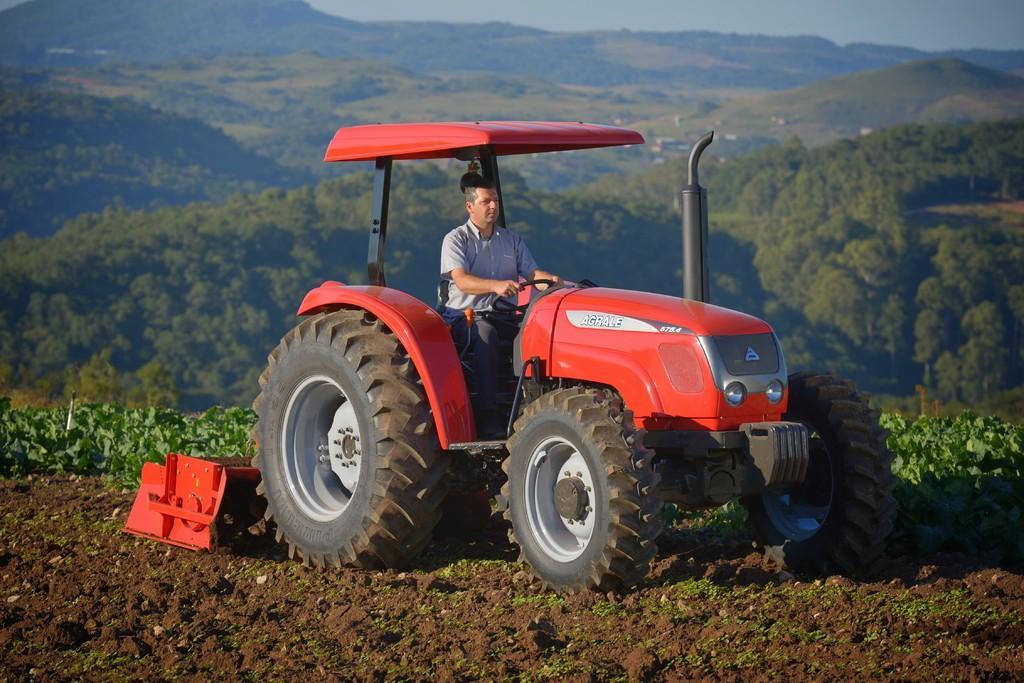In one or two sentences, can you explain what this image depicts? In this image we can see a man is sitting on a vehicle. Background of the image mountains and trees are present. 